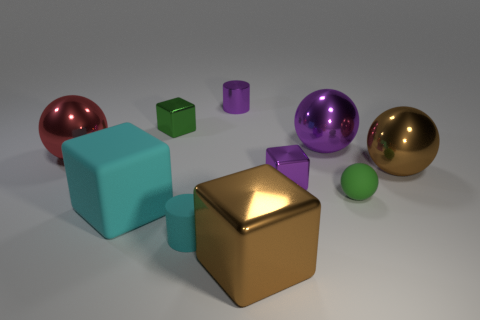Subtract all small green balls. How many balls are left? 3 Subtract all green blocks. How many blocks are left? 3 Subtract 1 spheres. How many spheres are left? 3 Add 8 tiny metallic cylinders. How many tiny metallic cylinders exist? 9 Subtract 1 green blocks. How many objects are left? 9 Subtract all blocks. How many objects are left? 6 Subtract all purple cylinders. Subtract all red spheres. How many cylinders are left? 1 Subtract all small matte objects. Subtract all green metallic objects. How many objects are left? 7 Add 1 large red spheres. How many large red spheres are left? 2 